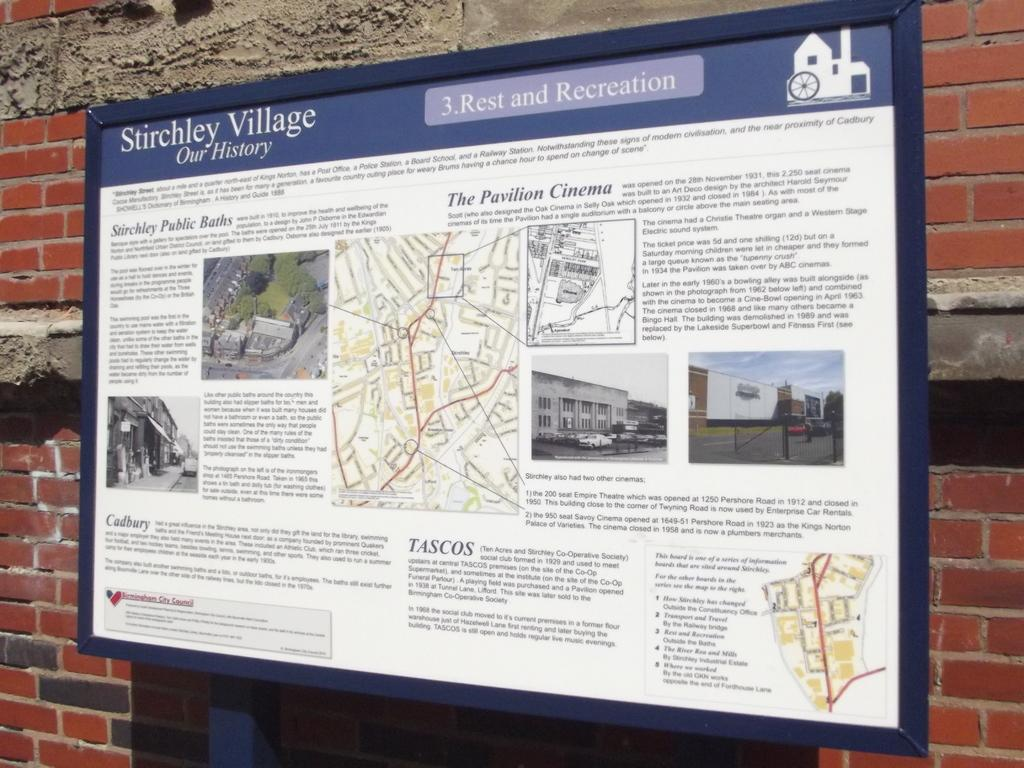What is depicted on the board in the image? There is a geographical map and route on a board in the image. What can be seen behind the board? The board is in front of a wall with bricks. How many ducks are sitting on the geographical map in the image? There are no ducks present in the image; it features a geographical map and route on a board. 